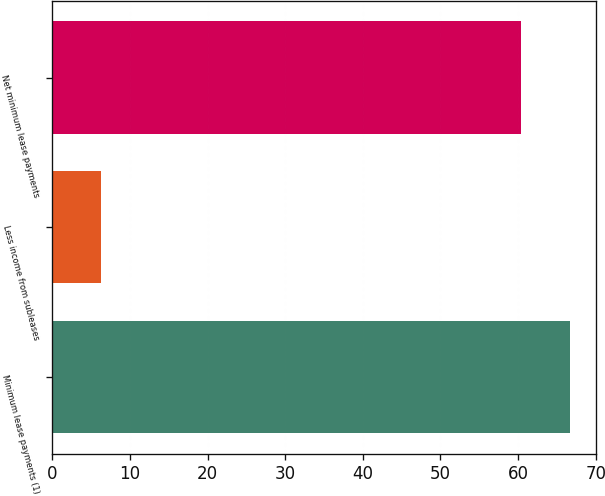<chart> <loc_0><loc_0><loc_500><loc_500><bar_chart><fcel>Minimum lease payments (1)<fcel>Less income from subleases<fcel>Net minimum lease payments<nl><fcel>66.7<fcel>6.3<fcel>60.4<nl></chart> 